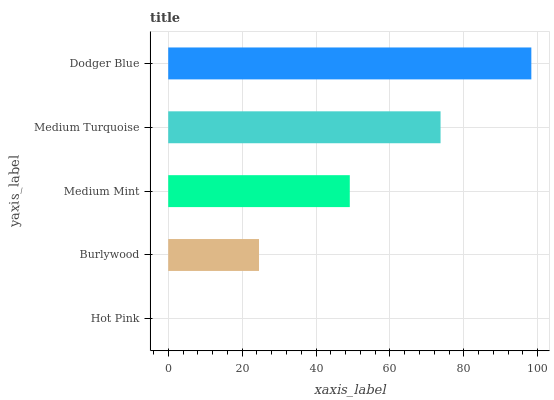Is Hot Pink the minimum?
Answer yes or no. Yes. Is Dodger Blue the maximum?
Answer yes or no. Yes. Is Burlywood the minimum?
Answer yes or no. No. Is Burlywood the maximum?
Answer yes or no. No. Is Burlywood greater than Hot Pink?
Answer yes or no. Yes. Is Hot Pink less than Burlywood?
Answer yes or no. Yes. Is Hot Pink greater than Burlywood?
Answer yes or no. No. Is Burlywood less than Hot Pink?
Answer yes or no. No. Is Medium Mint the high median?
Answer yes or no. Yes. Is Medium Mint the low median?
Answer yes or no. Yes. Is Hot Pink the high median?
Answer yes or no. No. Is Burlywood the low median?
Answer yes or no. No. 